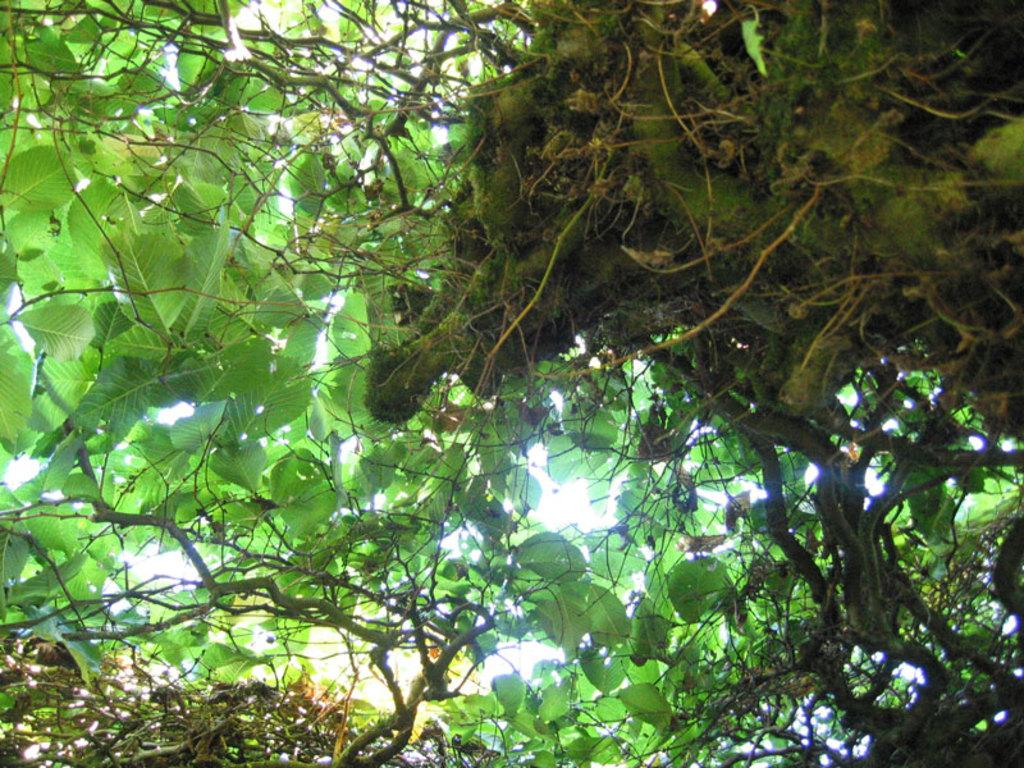What type of vegetation can be seen in the image? There are trees in the image. Reasoning: Let's think step by step by step in order to produce the conversation. We start with the only fact provided, which is that there are trees in the image. We formulate a question that focuses on the type of vegetation present, ensuring that the answer can be definitively determined from the given information. Absurd Question/Answer: What type of insurance policy is being discussed in the image? There is no mention of insurance or any discussion in the image, as it only features trees. 